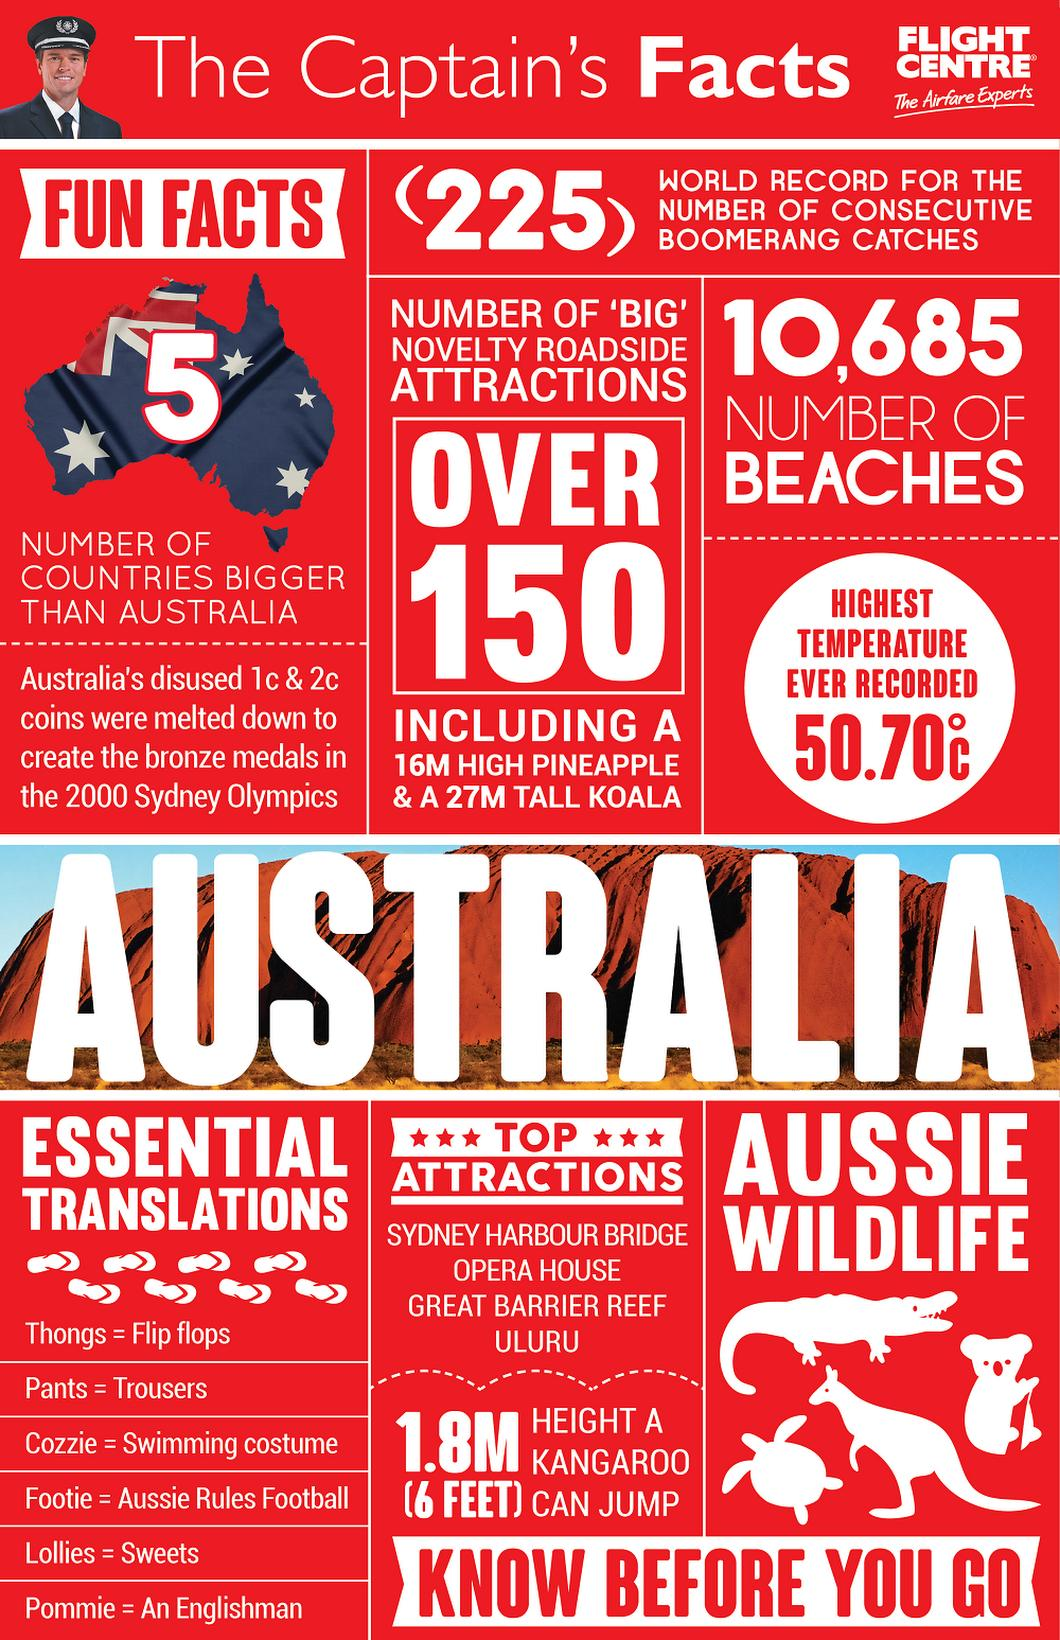Outline some significant characteristics in this image. Four wildlife pictures are displayed in the document. There are five countries that are larger than Australia. The count 10,685 represents the number of beaches in a certain area. The creation of bronze medals in Australia involved melting down outdated 1c and 2c coins that were no longer in use. The height difference between a pineapple and a koala is 11. 